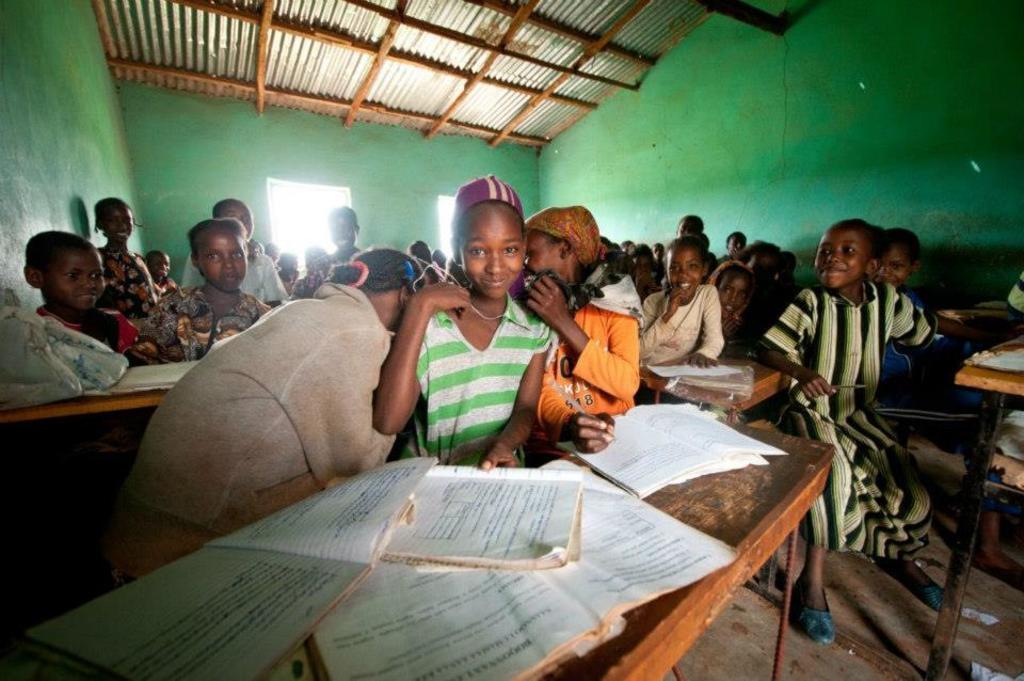Can you describe this image briefly? In this image I can see there are group of children's visible in front of table, on the table I can see books,at the top I can see roofs and there are windows visible in the middle. 